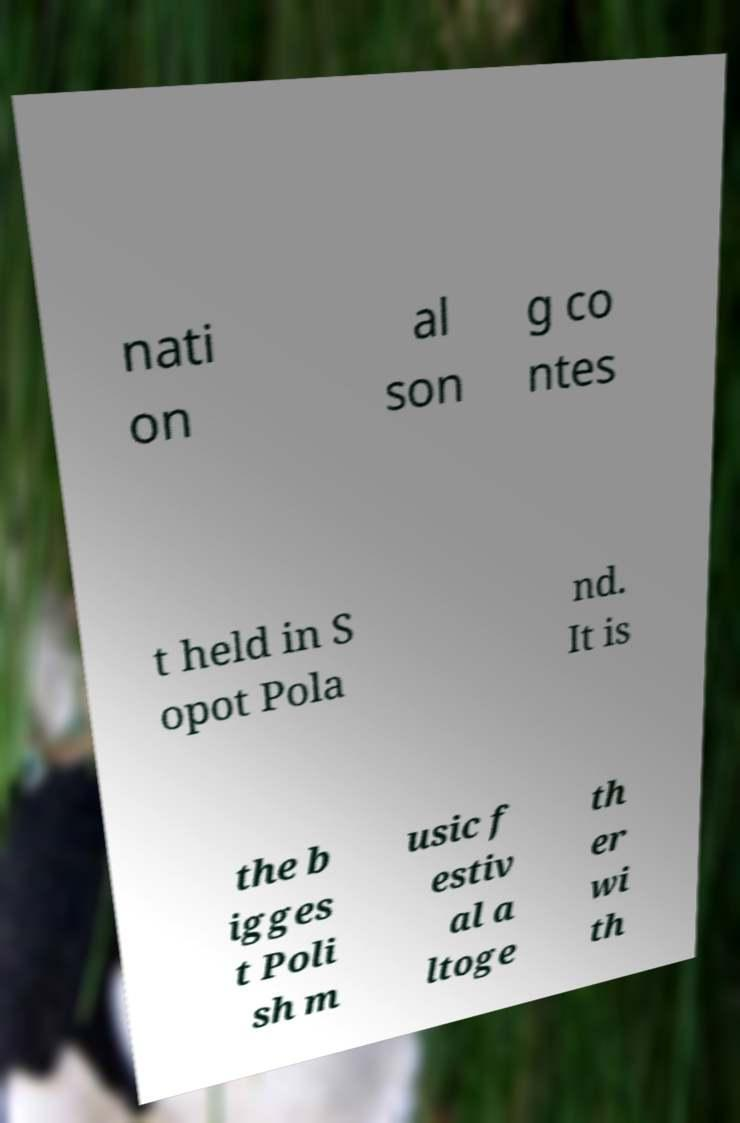Can you accurately transcribe the text from the provided image for me? nati on al son g co ntes t held in S opot Pola nd. It is the b igges t Poli sh m usic f estiv al a ltoge th er wi th 